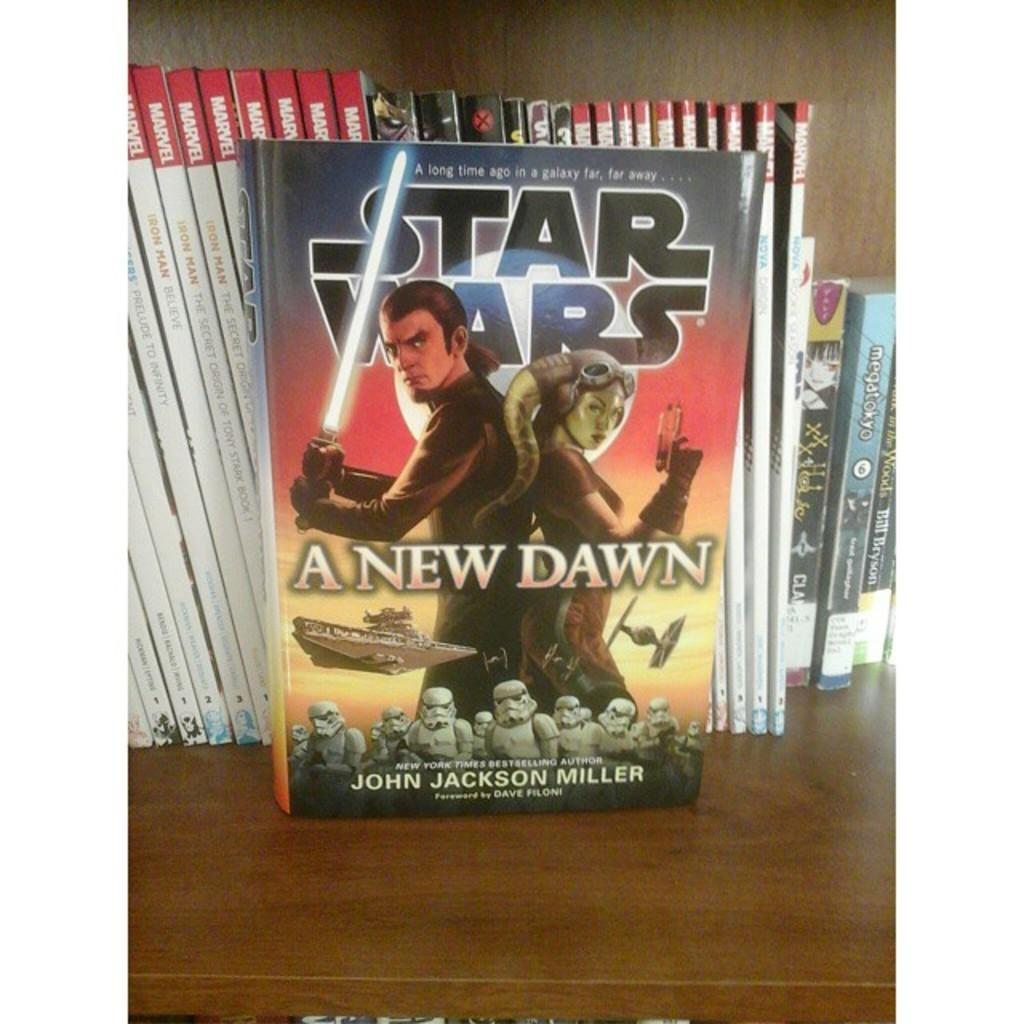<image>
Summarize the visual content of the image. The Star Wars book is called A New Dawn 